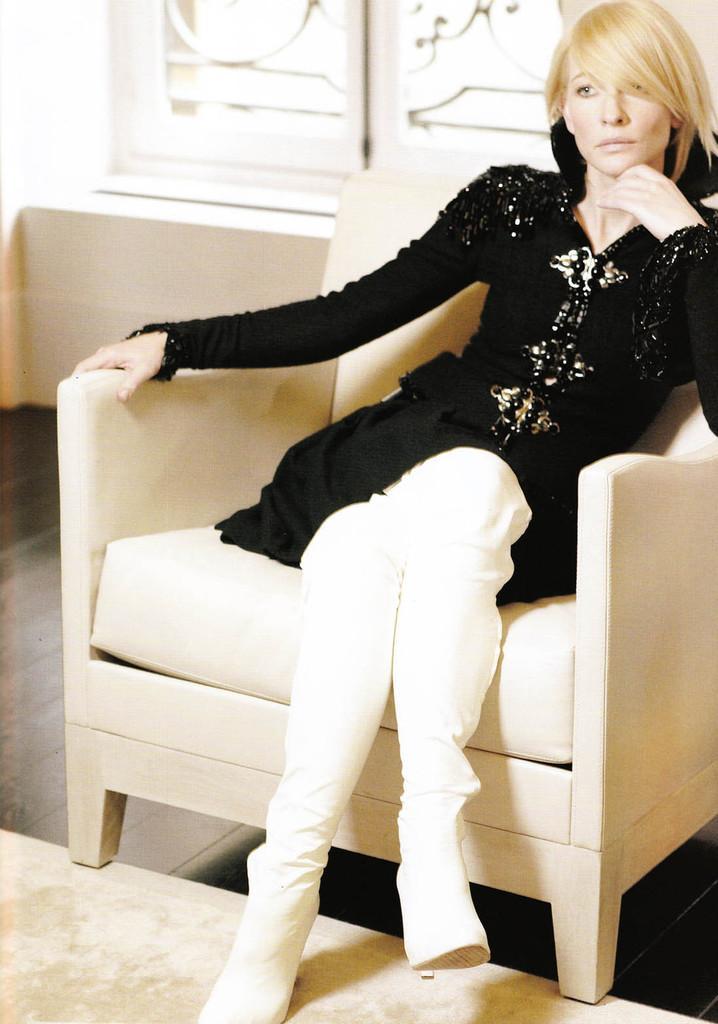In one or two sentences, can you explain what this image depicts? This is the picture of a lady wearing black top and white pant sitting on the sofa. 